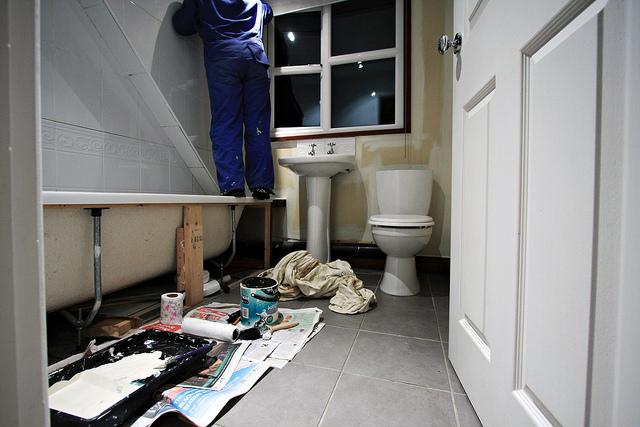Where is the man leaning?
Keep it brief. Wall. What is the floor made of?
Short answer required. Tile. What is hanging in the window?
Short answer required. Nothing. What is the substance inside the black tray?
Be succinct. Paint. What is the person wearing?
Quick response, please. Jeans. How old is the child?
Concise answer only. 10. 